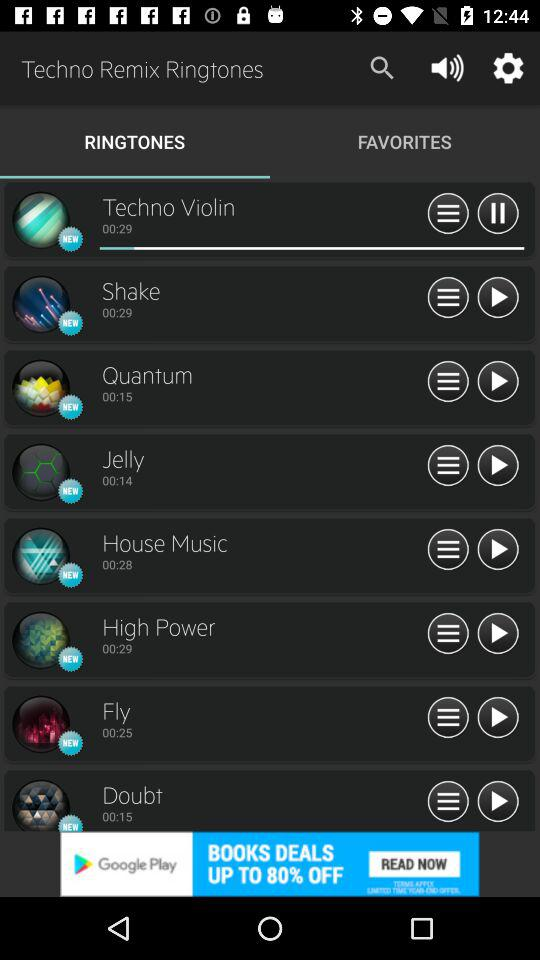How many seconds longer is the song called Techno Violin than the song called Fly?
Answer the question using a single word or phrase. 4 